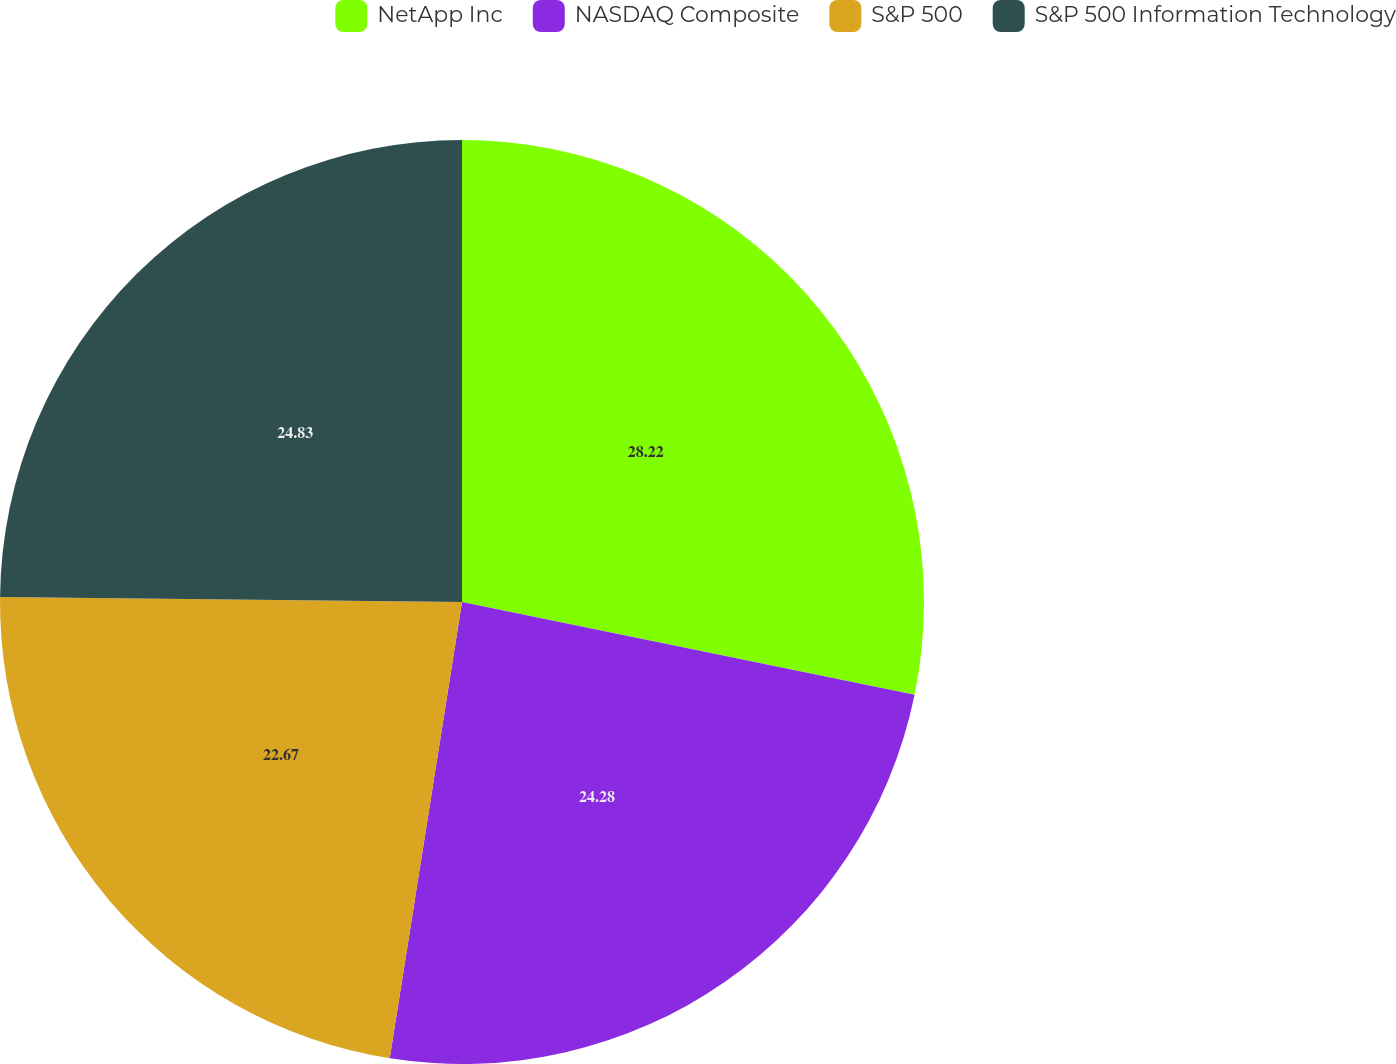Convert chart. <chart><loc_0><loc_0><loc_500><loc_500><pie_chart><fcel>NetApp Inc<fcel>NASDAQ Composite<fcel>S&P 500<fcel>S&P 500 Information Technology<nl><fcel>28.22%<fcel>24.28%<fcel>22.67%<fcel>24.83%<nl></chart> 